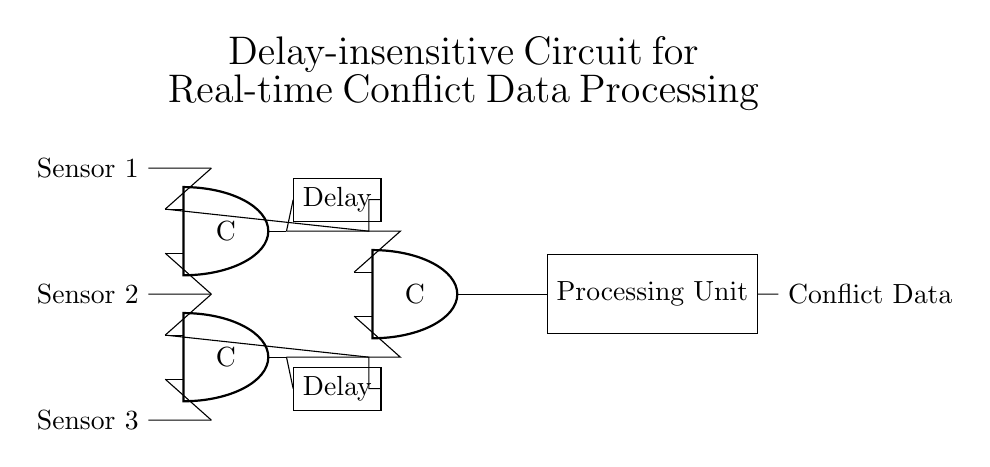What type of processing unit is used in this circuit? The circuit diagram shows a rectangle labeled "Processing Unit," which indicates that it is a generic processing unit designed to handle the output from the Muller C-elements.
Answer: Processing Unit How many Muller C-elements are present in the circuit? By examining the circuit, I can identify three distinct Muller C-elements labeled C. Each one is represented as an "and port" in the diagram.
Answer: Three What is the main function of the delay elements in this circuit? The delay elements are used to ensure that the output of the Muller C-elements is synchronized with the input signals. This helps to manage timing issues, making the circuit delay-insensitive.
Answer: Synchronization Which sensors are connected to the first Muller C-element? The first Muller C-element connects to Sensor 1 and Sensor 2, as indicated by the lines leading to its inputs. Sensor 1 connects to input 1 and Sensor 2 connects to input 2 of this element.
Answer: Sensor 1 and Sensor 2 How does the output of the Muller C-elements connect to the processing unit? The output of the third Muller C-element connects directly to the west side of the processing unit with a single line, showing that it sends processed data directly to the unit.
Answer: Directly What is the purpose of the overall circuit design being delay-insensitive? The delay-insensitive design allows for real-time processing of conflict data, meaning the circuit can function effectively without waiting for signals to stabilize, which is crucial in conflict analysis scenarios.
Answer: Real-time processing 